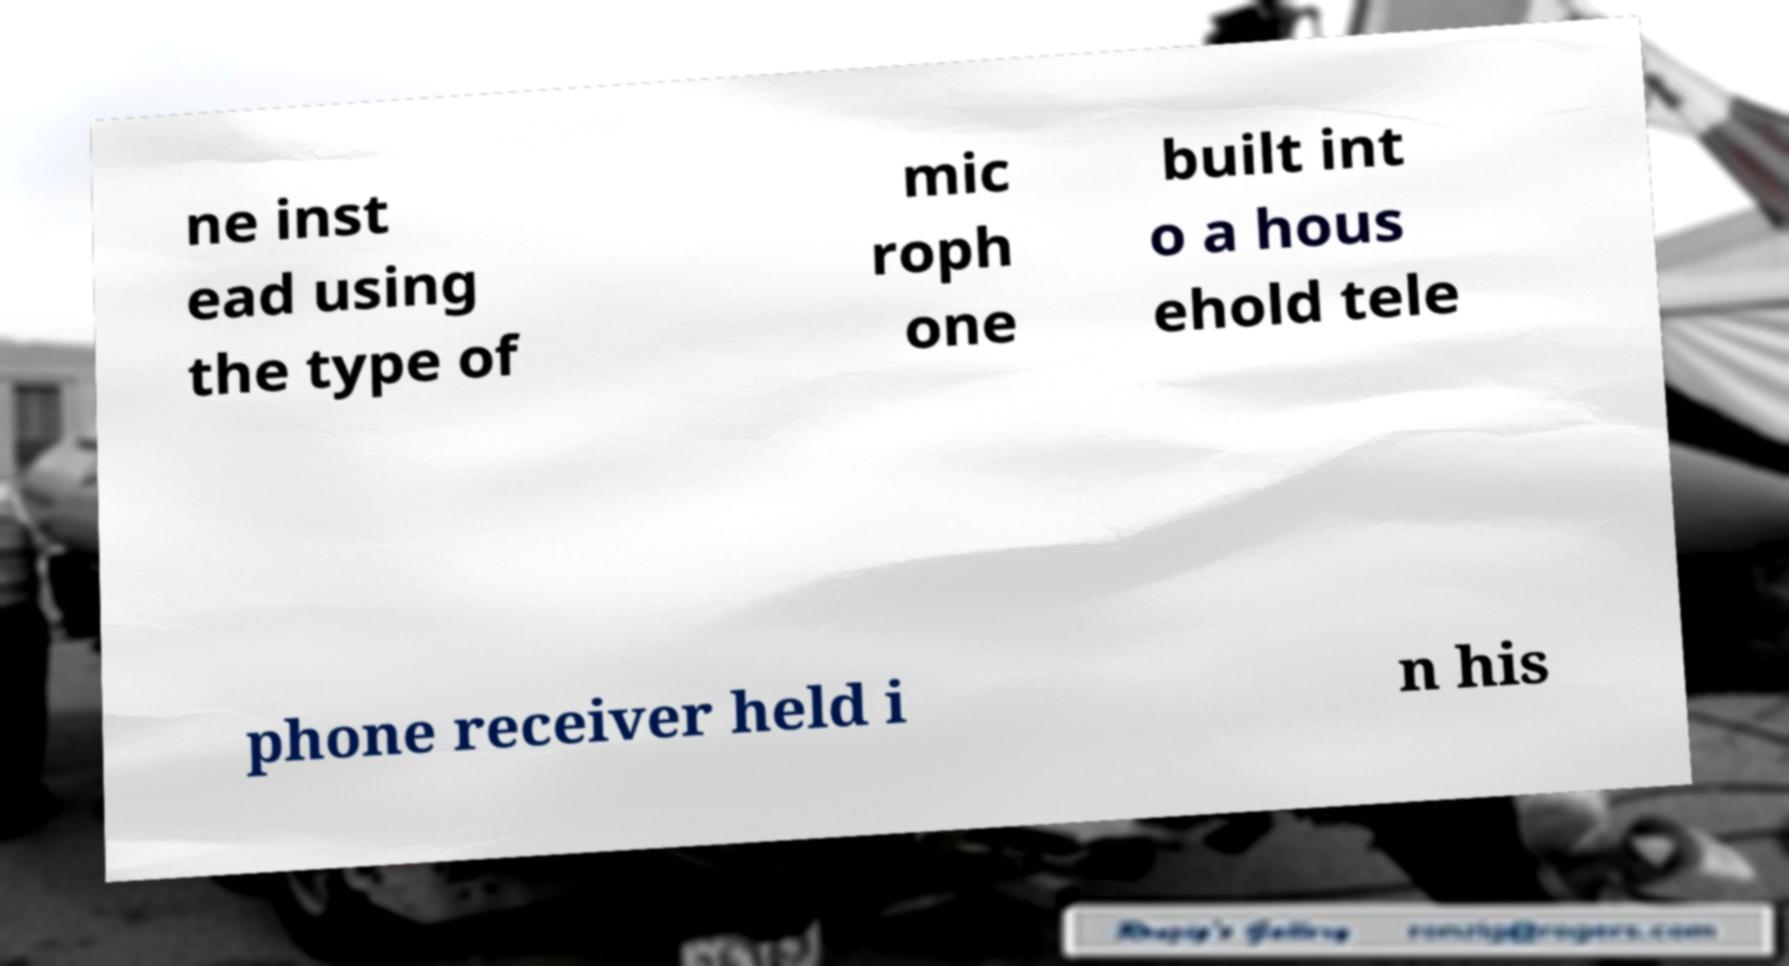For documentation purposes, I need the text within this image transcribed. Could you provide that? ne inst ead using the type of mic roph one built int o a hous ehold tele phone receiver held i n his 